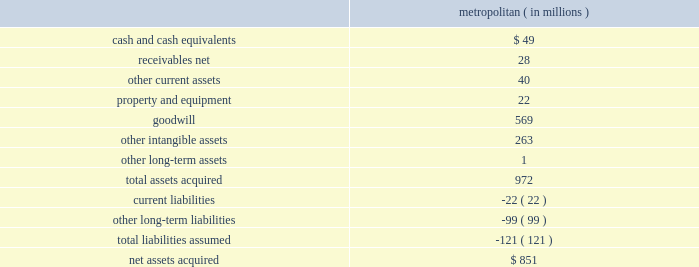Humana inc .
Notes to consolidated financial statements 2014 ( continued ) not be estimated based on observable market prices , and as such , unobservable inputs were used .
For auction rate securities , valuation methodologies include consideration of the quality of the sector and issuer , underlying collateral , underlying final maturity dates , and liquidity .
Recently issued accounting pronouncements there are no recently issued accounting standards that apply to us or that will have a material impact on our results of operations , financial condition , or cash flows .
Acquisitions on december 21 , 2012 , we acquired metropolitan health networks , inc. , or metropolitan , a medical services organization , or mso , that coordinates medical care for medicare advantage beneficiaries and medicaid recipients , primarily in florida .
We paid $ 11.25 per share in cash to acquire all of the outstanding shares of metropolitan and repaid all outstanding debt of metropolitan for a transaction value of $ 851 million , plus transaction expenses .
The preliminary fair values of metropolitan 2019s assets acquired and liabilities assumed at the date of the acquisition are summarized as follows : metropolitan ( in millions ) .
The goodwill was assigned to the health and well-being services segment and is not deductible for tax purposes .
The other intangible assets , which primarily consist of customer contracts and trade names , have a weighted average useful life of 8.4 years .
On october 29 , 2012 , we acquired a noncontrolling equity interest in mcci holdings , llc , or mcci , a privately held mso headquartered in miami , florida that coordinates medical care for medicare advantage and medicaid beneficiaries primarily in florida and texas .
The metropolitan and mcci transactions are expected to provide us with components of a successful integrated care delivery model that has demonstrated scalability to new markets .
A substantial portion of the revenues for both metropolitan and mcci are derived from services provided to humana medicare advantage members under capitation contracts with our health plans .
In addition , metropolitan and mcci provide services to medicare advantage and medicaid members under capitation contracts with third party health plans .
Under these capitation agreements with humana and third party health plans , metropolitan and mcci assume financial risk associated with these medicare advantage and medicaid members. .
What is the working capital of metropolitan? 
Computations: (((49 + 28) + 40) - 22)
Answer: 95.0. 